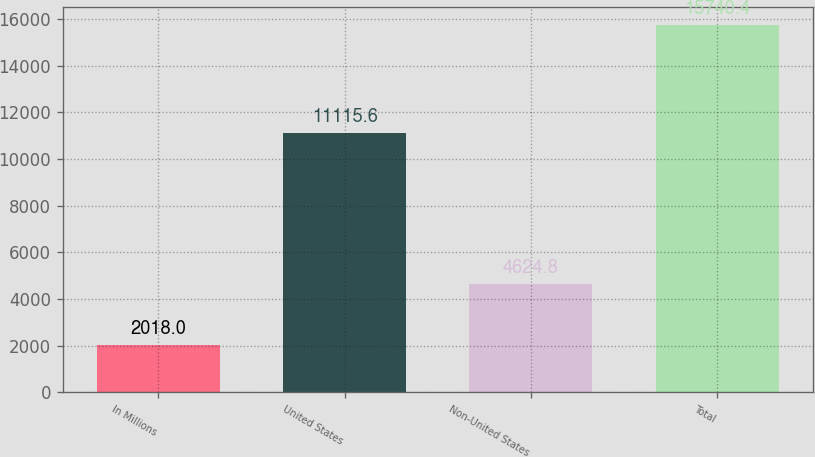Convert chart. <chart><loc_0><loc_0><loc_500><loc_500><bar_chart><fcel>In Millions<fcel>United States<fcel>Non-United States<fcel>Total<nl><fcel>2018<fcel>11115.6<fcel>4624.8<fcel>15740.4<nl></chart> 